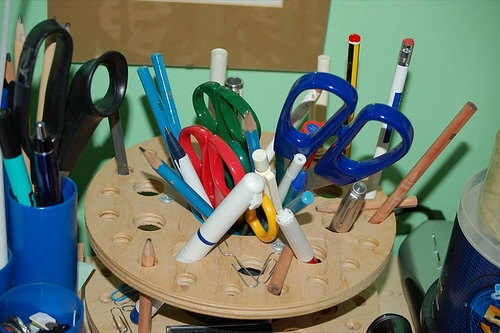Describe the objects in this image and their specific colors. I can see scissors in teal, navy, darkblue, turquoise, and gray tones, scissors in teal, black, darkgray, tan, and turquoise tones, scissors in teal, brown, black, and olive tones, scissors in teal and darkgreen tones, and scissors in teal, orange, olive, black, and maroon tones in this image. 